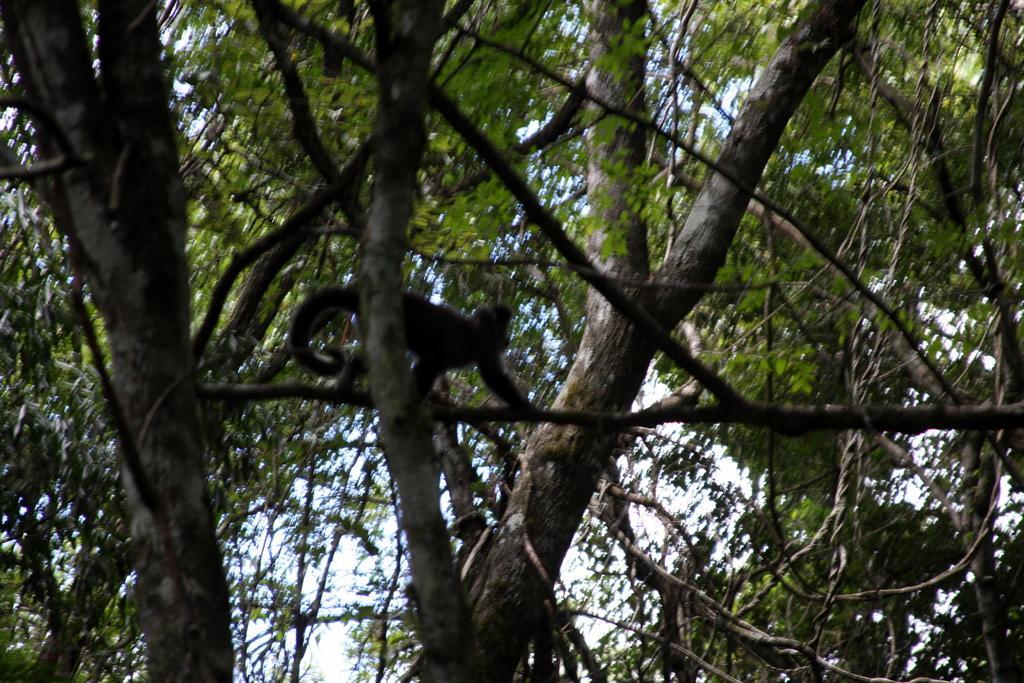Describe this image in one or two sentences. In this image, we can see a monkey is walking on the tree stem. Background we can see trees and sky. 